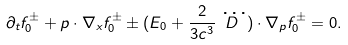Convert formula to latex. <formula><loc_0><loc_0><loc_500><loc_500>\partial _ { t } f _ { 0 } ^ { \pm } + p \cdot \nabla _ { x } f ^ { \pm } _ { 0 } \pm ( E _ { 0 } + \frac { 2 } { 3 c ^ { 3 } } \dddot { D } ) \cdot \nabla _ { p } f ^ { \pm } _ { 0 } = 0 .</formula> 